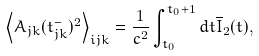<formula> <loc_0><loc_0><loc_500><loc_500>\left \langle A _ { j k } ( t _ { j k } ^ { - } ) ^ { 2 } \right \rangle _ { i j k } = \frac { 1 } { c ^ { 2 } } \int _ { t _ { 0 } } ^ { t _ { 0 } + 1 } d t \overline { I } _ { 2 } ( t ) ,</formula> 